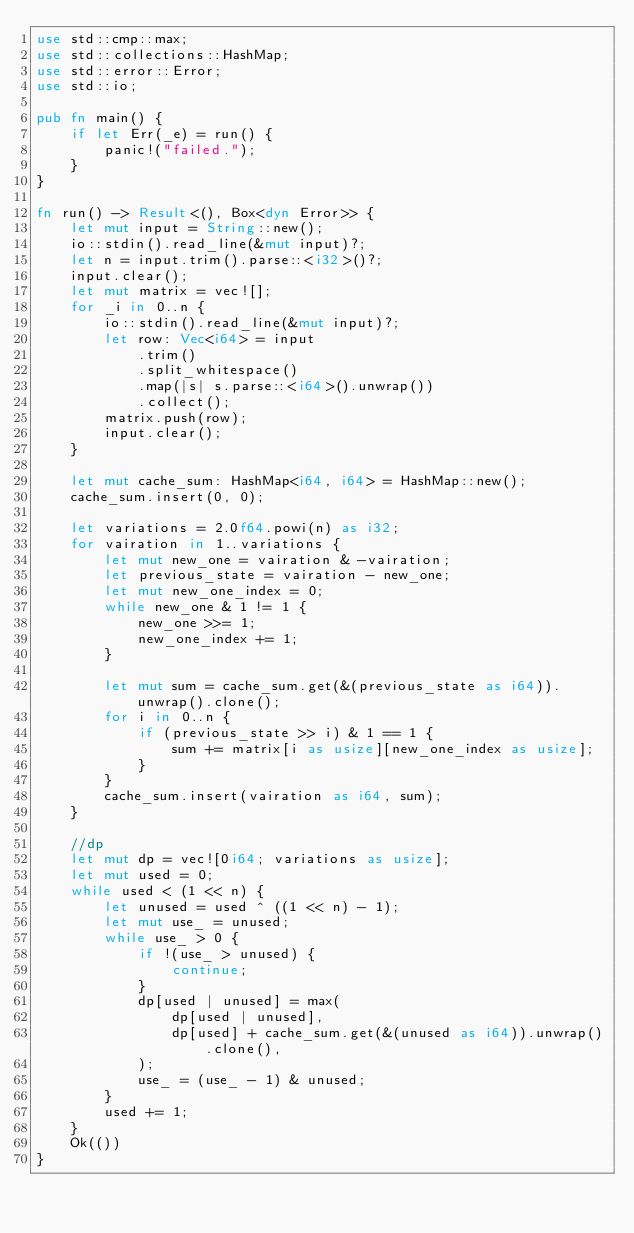Convert code to text. <code><loc_0><loc_0><loc_500><loc_500><_Rust_>use std::cmp::max;
use std::collections::HashMap;
use std::error::Error;
use std::io;

pub fn main() {
    if let Err(_e) = run() {
        panic!("failed.");
    }
}

fn run() -> Result<(), Box<dyn Error>> {
    let mut input = String::new();
    io::stdin().read_line(&mut input)?;
    let n = input.trim().parse::<i32>()?;
    input.clear();
    let mut matrix = vec![];
    for _i in 0..n {
        io::stdin().read_line(&mut input)?;
        let row: Vec<i64> = input
            .trim()
            .split_whitespace()
            .map(|s| s.parse::<i64>().unwrap())
            .collect();
        matrix.push(row);
        input.clear();
    }

    let mut cache_sum: HashMap<i64, i64> = HashMap::new();
    cache_sum.insert(0, 0);

    let variations = 2.0f64.powi(n) as i32;
    for vairation in 1..variations {
        let mut new_one = vairation & -vairation;
        let previous_state = vairation - new_one;
        let mut new_one_index = 0;
        while new_one & 1 != 1 {
            new_one >>= 1;
            new_one_index += 1;
        }

        let mut sum = cache_sum.get(&(previous_state as i64)).unwrap().clone();
        for i in 0..n {
            if (previous_state >> i) & 1 == 1 {
                sum += matrix[i as usize][new_one_index as usize];
            }
        }
        cache_sum.insert(vairation as i64, sum);
    }

    //dp
    let mut dp = vec![0i64; variations as usize];
    let mut used = 0;
    while used < (1 << n) {
        let unused = used ^ ((1 << n) - 1);
        let mut use_ = unused;
        while use_ > 0 {
            if !(use_ > unused) {
                continue;
            }
            dp[used | unused] = max(
                dp[used | unused],
                dp[used] + cache_sum.get(&(unused as i64)).unwrap().clone(),
            );
            use_ = (use_ - 1) & unused;
        }
        used += 1;
    }
    Ok(())
}
</code> 